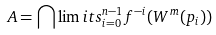Convert formula to latex. <formula><loc_0><loc_0><loc_500><loc_500>A = \bigcap \lim i t s _ { i = 0 } ^ { n - 1 } f ^ { - i } ( W ^ { m } ( p _ { i } ) )</formula> 